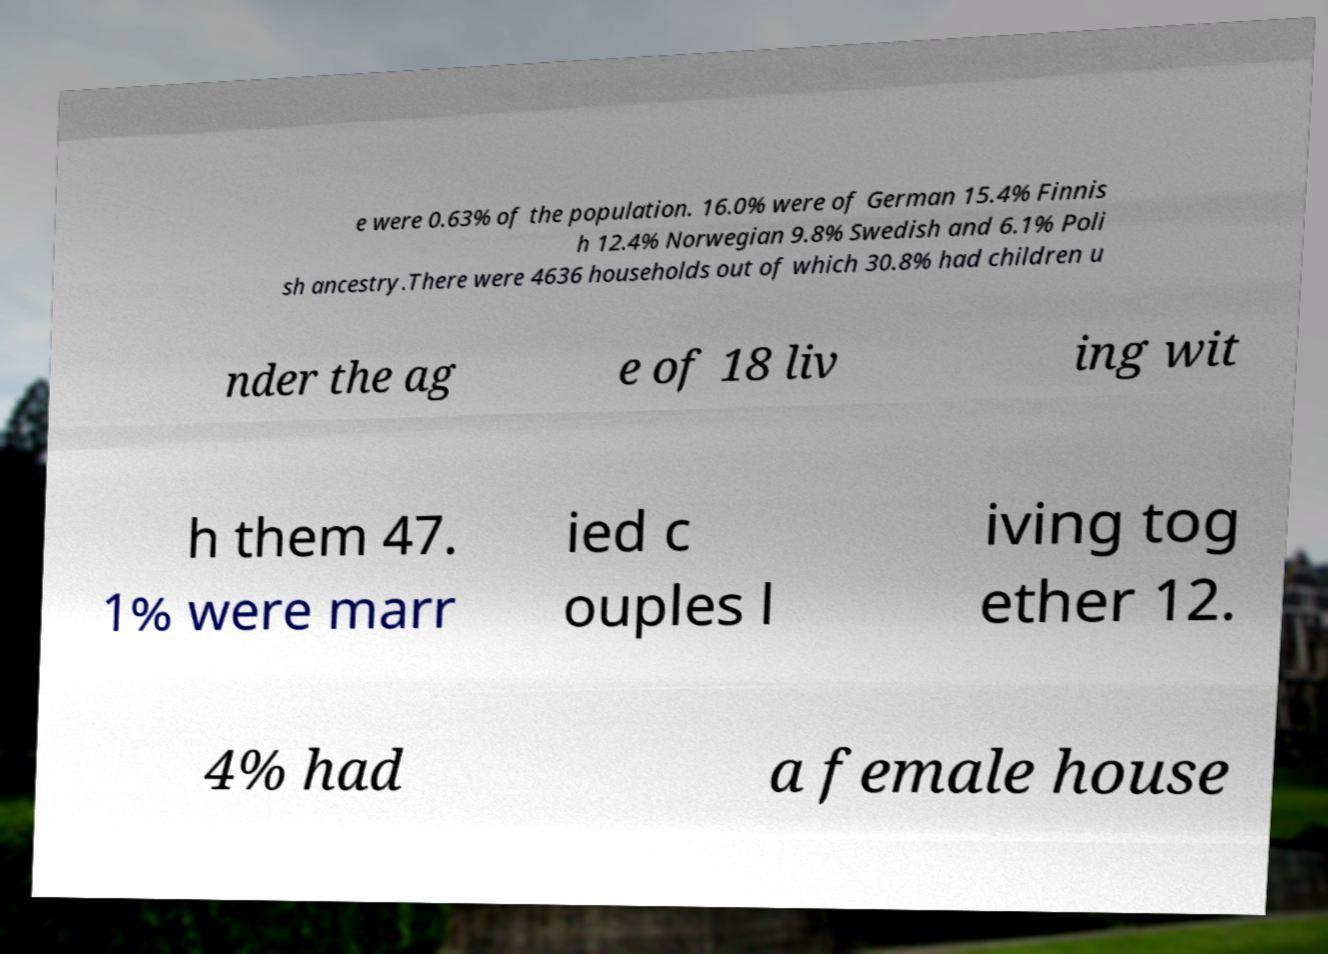I need the written content from this picture converted into text. Can you do that? e were 0.63% of the population. 16.0% were of German 15.4% Finnis h 12.4% Norwegian 9.8% Swedish and 6.1% Poli sh ancestry.There were 4636 households out of which 30.8% had children u nder the ag e of 18 liv ing wit h them 47. 1% were marr ied c ouples l iving tog ether 12. 4% had a female house 